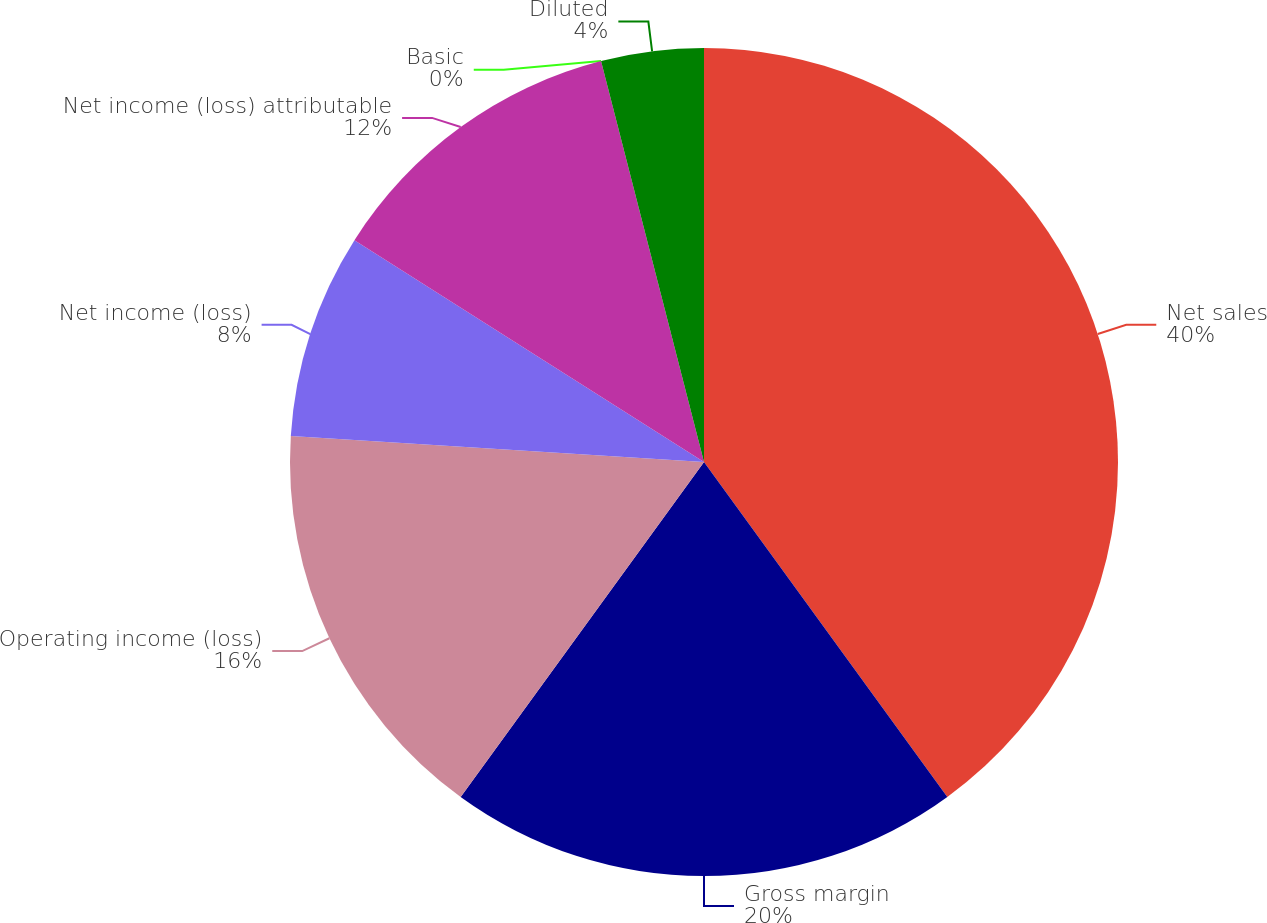Convert chart. <chart><loc_0><loc_0><loc_500><loc_500><pie_chart><fcel>Net sales<fcel>Gross margin<fcel>Operating income (loss)<fcel>Net income (loss)<fcel>Net income (loss) attributable<fcel>Basic<fcel>Diluted<nl><fcel>40.0%<fcel>20.0%<fcel>16.0%<fcel>8.0%<fcel>12.0%<fcel>0.0%<fcel>4.0%<nl></chart> 